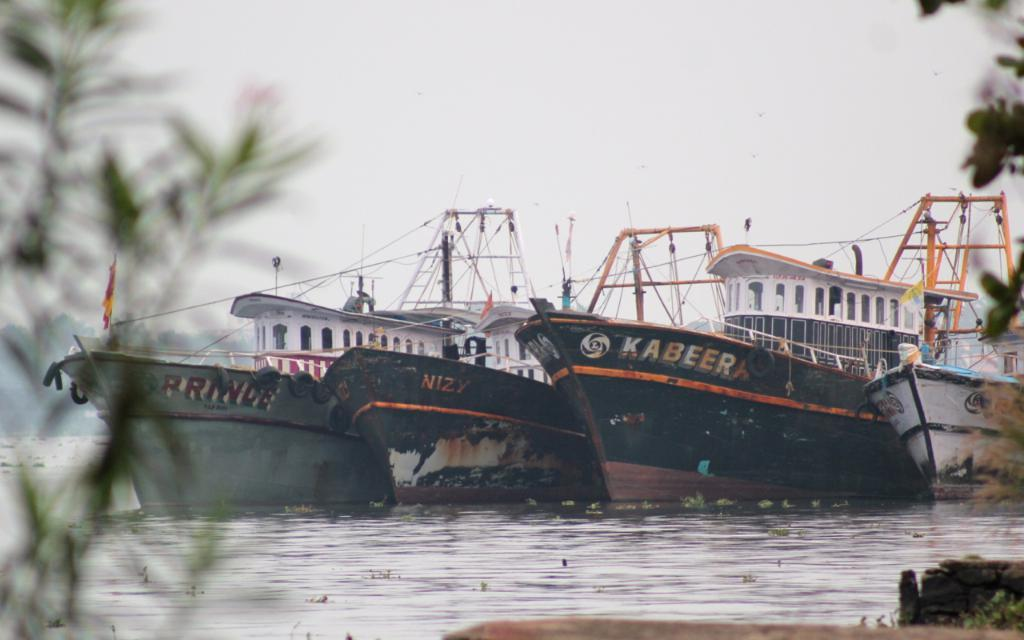What is on the water in the image? There are ships on the water in the image. What type of structures can be seen in the image? There are poles and other metal objects in the image. What type of vegetation is present in the image? There are plants on the left and right sides of the image, and trees in the background of the image. What is visible in the background of the image? The sky is visible in the background of the image. What type of bell can be heard ringing in the image? There is no bell present in the image, and therefore no sound can be heard. What type of beef dish is being prepared on the ships in the image? There is no beef dish or any cooking activity depicted in the image. 